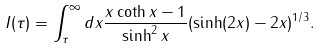Convert formula to latex. <formula><loc_0><loc_0><loc_500><loc_500>I ( \tau ) = \int _ { \tau } ^ { \infty } d x \frac { x \coth x - 1 } { \sinh ^ { 2 } x } ( \sinh ( 2 x ) - 2 x ) ^ { 1 / 3 } .</formula> 